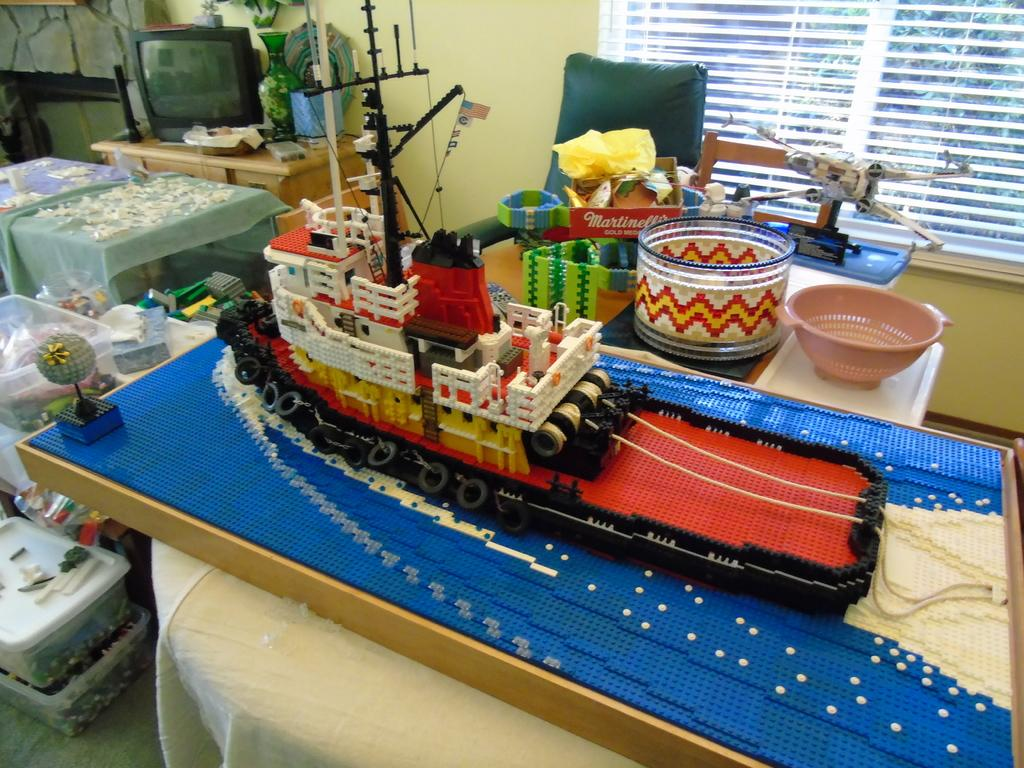What is located on the left side of the image? There is a TV on the left side of the image. What can be seen on the table in the image? There is a flower vase on a table in the image. What type of furniture is present in the image? There is a chair in the image. What is the purpose of the basket in the image? The purpose of the basket in the image is not specified, but it could be used for storage or decoration. What is the subject of the image? The subject of the image is a ship. What can be seen in the background of the image? There is a wall and a window in the background of the image. How many dolls are sitting on the chair in the image? There are no dolls present in the image; it features a TV, a flower vase, a chair, a basket, a ship, a wall, and a window. What form of transportation is used by the belief system depicted in the image? There is no belief system or transportation depicted in the image; it features a TV, a flower vase, a chair, a basket, a ship, a wall, and a window. 